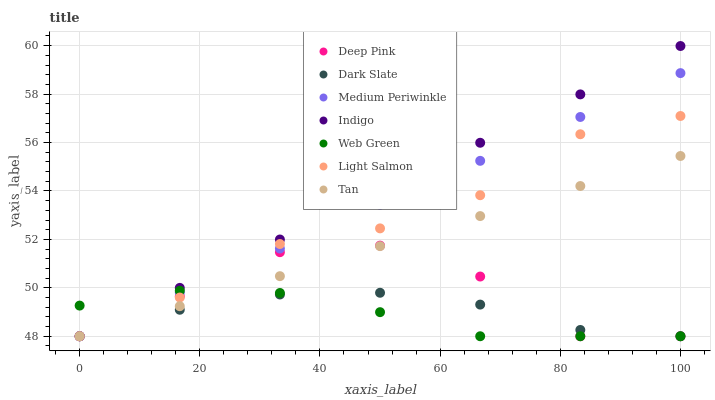Does Web Green have the minimum area under the curve?
Answer yes or no. Yes. Does Indigo have the maximum area under the curve?
Answer yes or no. Yes. Does Deep Pink have the minimum area under the curve?
Answer yes or no. No. Does Deep Pink have the maximum area under the curve?
Answer yes or no. No. Is Tan the smoothest?
Answer yes or no. Yes. Is Deep Pink the roughest?
Answer yes or no. Yes. Is Indigo the smoothest?
Answer yes or no. No. Is Indigo the roughest?
Answer yes or no. No. Does Light Salmon have the lowest value?
Answer yes or no. Yes. Does Indigo have the highest value?
Answer yes or no. Yes. Does Deep Pink have the highest value?
Answer yes or no. No. Does Light Salmon intersect Medium Periwinkle?
Answer yes or no. Yes. Is Light Salmon less than Medium Periwinkle?
Answer yes or no. No. Is Light Salmon greater than Medium Periwinkle?
Answer yes or no. No. 